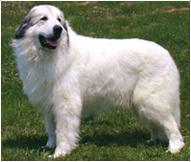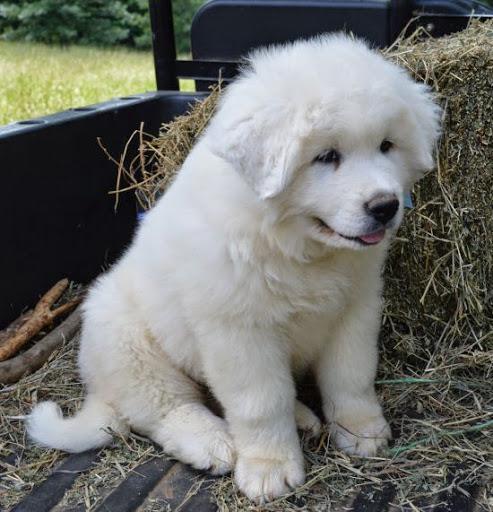The first image is the image on the left, the second image is the image on the right. Assess this claim about the two images: "An image contains at least two dogs.". Correct or not? Answer yes or no. No. The first image is the image on the left, the second image is the image on the right. Examine the images to the left and right. Is the description "Two furry white dogs pose standing close together outdoors, in one image." accurate? Answer yes or no. No. 